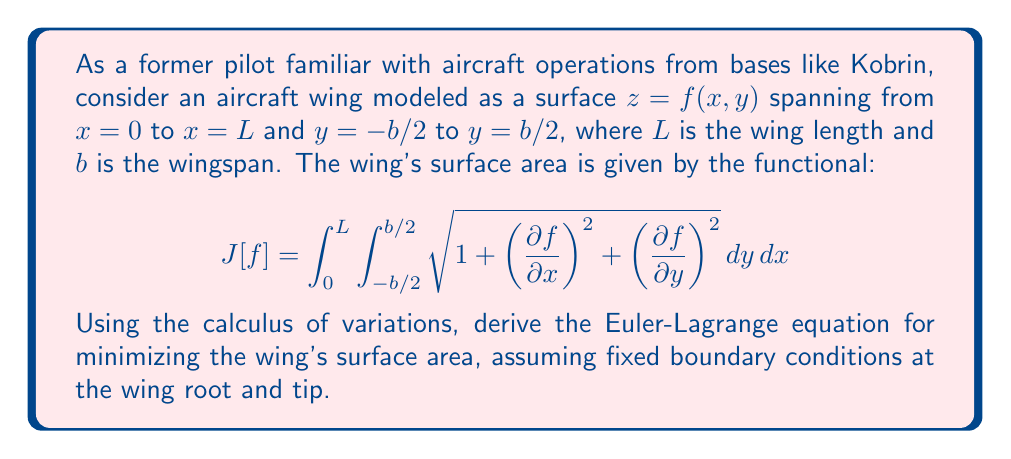Can you solve this math problem? Let's approach this step-by-step:

1) The functional for surface area is given by:

   $$J[f] = \int_{0}^{L} \int_{-b/2}^{b/2} \sqrt{1 + \left(\frac{\partial f}{\partial x}\right)^2 + \left(\frac{\partial f}{\partial y}\right)^2} \, dy \, dx$$

2) Let's denote the integrand as $F(x, y, f, f_x, f_y)$, where $f_x = \frac{\partial f}{\partial x}$ and $f_y = \frac{\partial f}{\partial y}$:

   $$F = \sqrt{1 + f_x^2 + f_y^2}$$

3) The Euler-Lagrange equation for a functional of two independent variables is:

   $$\frac{\partial F}{\partial f} - \frac{\partial}{\partial x}\left(\frac{\partial F}{\partial f_x}\right) - \frac{\partial}{\partial y}\left(\frac{\partial F}{\partial f_y}\right) = 0$$

4) Let's calculate the partial derivatives:

   $\frac{\partial F}{\partial f} = 0$

   $\frac{\partial F}{\partial f_x} = \frac{f_x}{\sqrt{1 + f_x^2 + f_y^2}}$

   $\frac{\partial F}{\partial f_y} = \frac{f_y}{\sqrt{1 + f_x^2 + f_y^2}}$

5) Now, we need to calculate:

   $$\frac{\partial}{\partial x}\left(\frac{f_x}{\sqrt{1 + f_x^2 + f_y^2}}\right) \text{ and } \frac{\partial}{\partial y}\left(\frac{f_y}{\sqrt{1 + f_x^2 + f_y^2}}\right)$$

6) Substituting these into the Euler-Lagrange equation:

   $$0 - \frac{\partial}{\partial x}\left(\frac{f_x}{\sqrt{1 + f_x^2 + f_y^2}}\right) - \frac{\partial}{\partial y}\left(\frac{f_y}{\sqrt{1 + f_x^2 + f_y^2}}\right) = 0$$

7) This simplifies to:

   $$\frac{\partial}{\partial x}\left(\frac{f_x}{\sqrt{1 + f_x^2 + f_y^2}}\right) + \frac{\partial}{\partial y}\left(\frac{f_y}{\sqrt{1 + f_x^2 + f_y^2}}\right) = 0$$

This is the Euler-Lagrange equation for minimizing the surface area of the wing.
Answer: $$\frac{\partial}{\partial x}\left(\frac{f_x}{\sqrt{1 + f_x^2 + f_y^2}}\right) + \frac{\partial}{\partial y}\left(\frac{f_y}{\sqrt{1 + f_x^2 + f_y^2}}\right) = 0$$ 